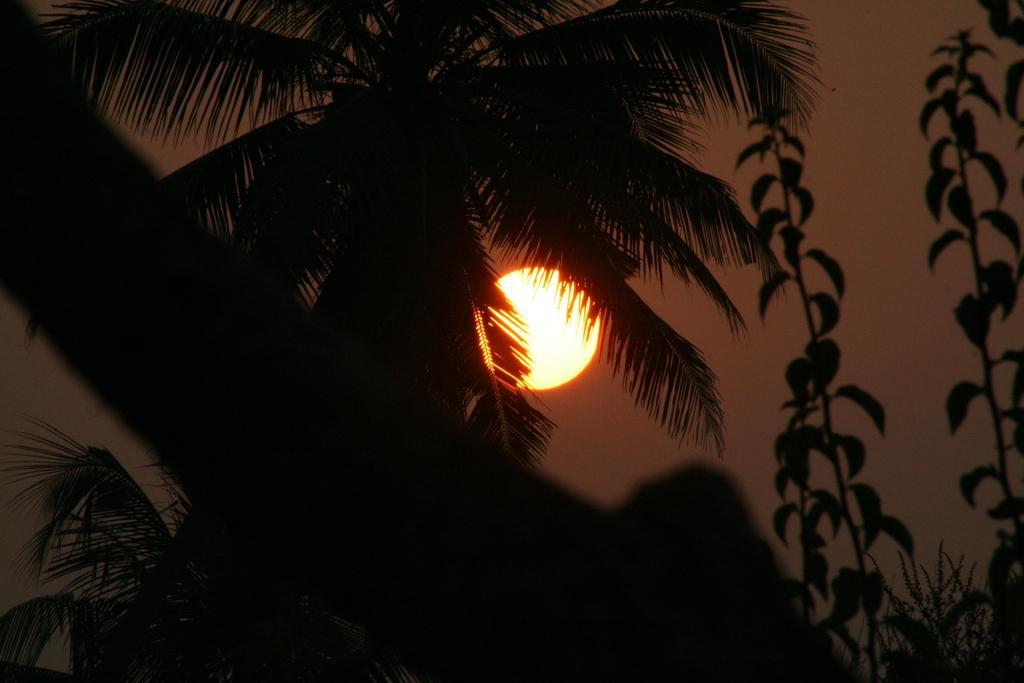Please provide a concise description of this image. In this picture we can see trees and in the background we can see the sky. 